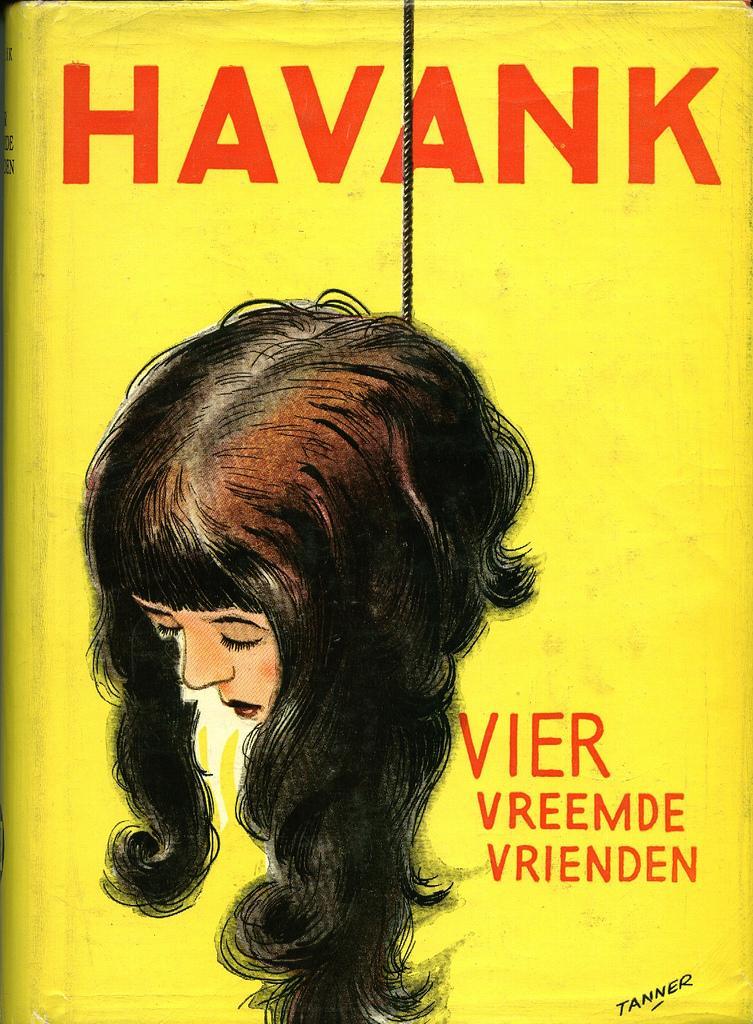Describe this image in one or two sentences. In this image there is poster on a book with a picture of a woman's head, rope and some text. 